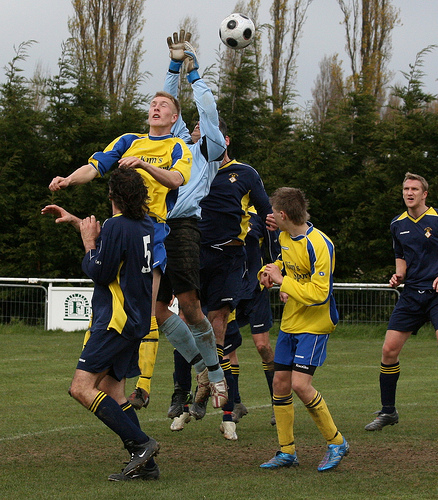<image>
Can you confirm if the player is behind the ball? Yes. From this viewpoint, the player is positioned behind the ball, with the ball partially or fully occluding the player. 